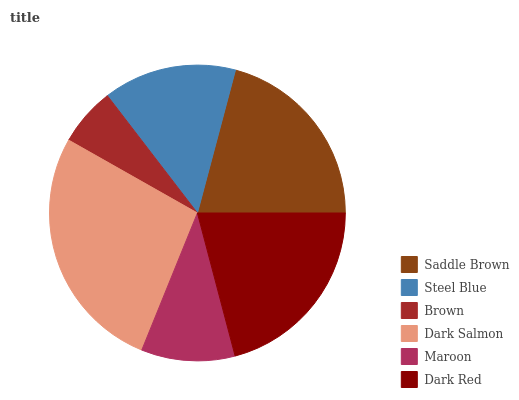Is Brown the minimum?
Answer yes or no. Yes. Is Dark Salmon the maximum?
Answer yes or no. Yes. Is Steel Blue the minimum?
Answer yes or no. No. Is Steel Blue the maximum?
Answer yes or no. No. Is Saddle Brown greater than Steel Blue?
Answer yes or no. Yes. Is Steel Blue less than Saddle Brown?
Answer yes or no. Yes. Is Steel Blue greater than Saddle Brown?
Answer yes or no. No. Is Saddle Brown less than Steel Blue?
Answer yes or no. No. Is Saddle Brown the high median?
Answer yes or no. Yes. Is Steel Blue the low median?
Answer yes or no. Yes. Is Brown the high median?
Answer yes or no. No. Is Brown the low median?
Answer yes or no. No. 